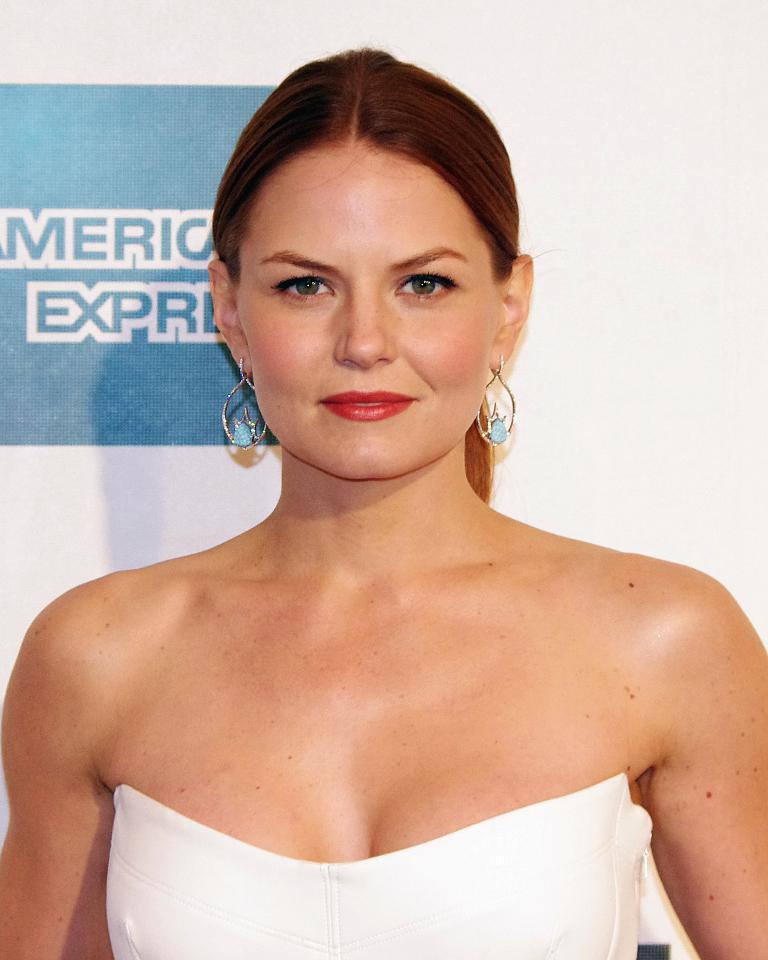Could you give a brief overview of what you see in this image? In the image there is a woman in white dress standing in front of white wall with a logo on the left side. 